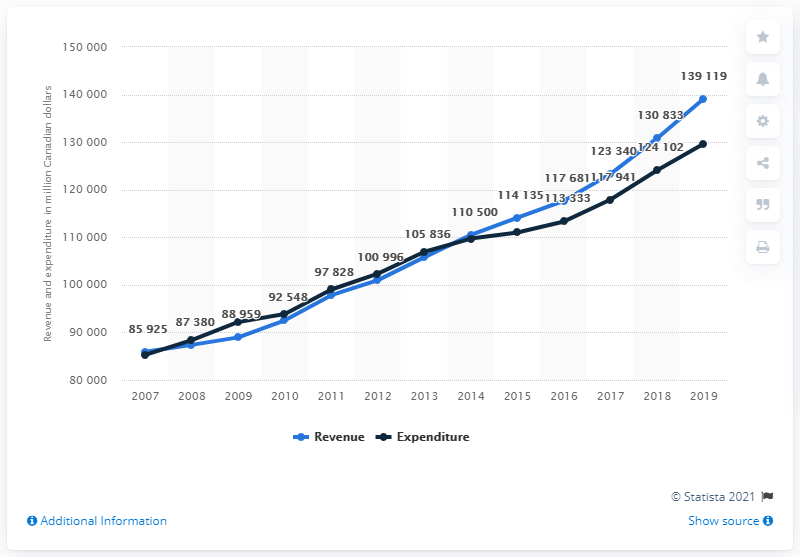Point out several critical features in this image. In 2019, the revenue of Quebec's provincial government was 139,119 dollars. 